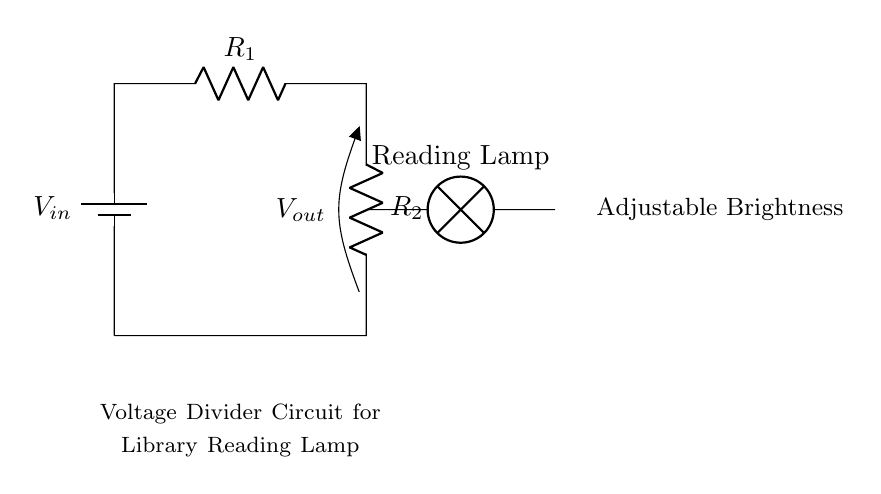What is the function of R1 in this circuit? R1 is a resistor in the voltage divider that works alongside R2 to divide the input voltage, influencing the output voltage across R2 and ultimately adjusting the brightness of the lamp.
Answer: Resistor How many resistors are present in the circuit? The circuit diagram includes two resistors labeled as R1 and R2, which are essential components of the voltage divider.
Answer: Two What is Vout used for in this circuit? Vout represents the output voltage across R2, which determines the voltage supplied to the reading lamp, thereby controlling its brightness.
Answer: Lamp brightness What happens if R2 is increased? Increasing R2 would lead to a higher output voltage Vout, as it will proportionally increase the voltage division, resulting in a brighter lamp since more voltage is available for the lamp.
Answer: Brighter lamp What type of circuit is depicted here? This is a voltage divider circuit, specifically designed to adjust voltage levels for applications such as dimming lights or lamps by dividing the input voltage.
Answer: Voltage divider What is the significance of the battery labeled Vin? The battery labeled Vin provides the input voltage required to power the circuit, which is essential for establishing the conditions under which the voltage divider operates.
Answer: Input voltage 